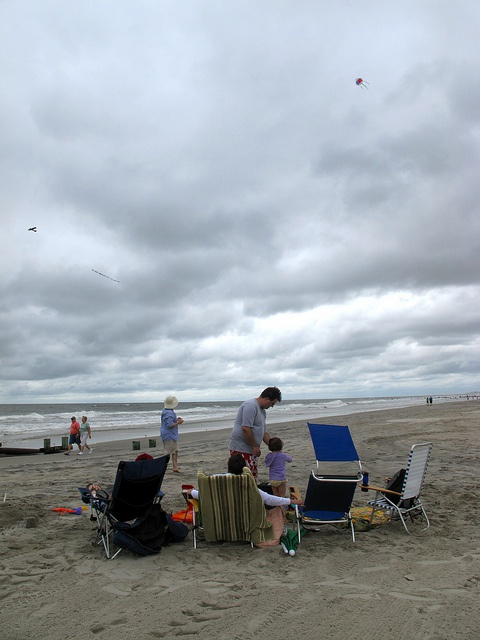Describe the objects in this image and their specific colors. I can see chair in lavender, black, darkgreen, and gray tones, chair in lavender, black, gray, purple, and navy tones, chair in lavender, black, and gray tones, chair in lavender, black, navy, and gray tones, and chair in lavender, navy, gray, black, and darkgray tones in this image. 